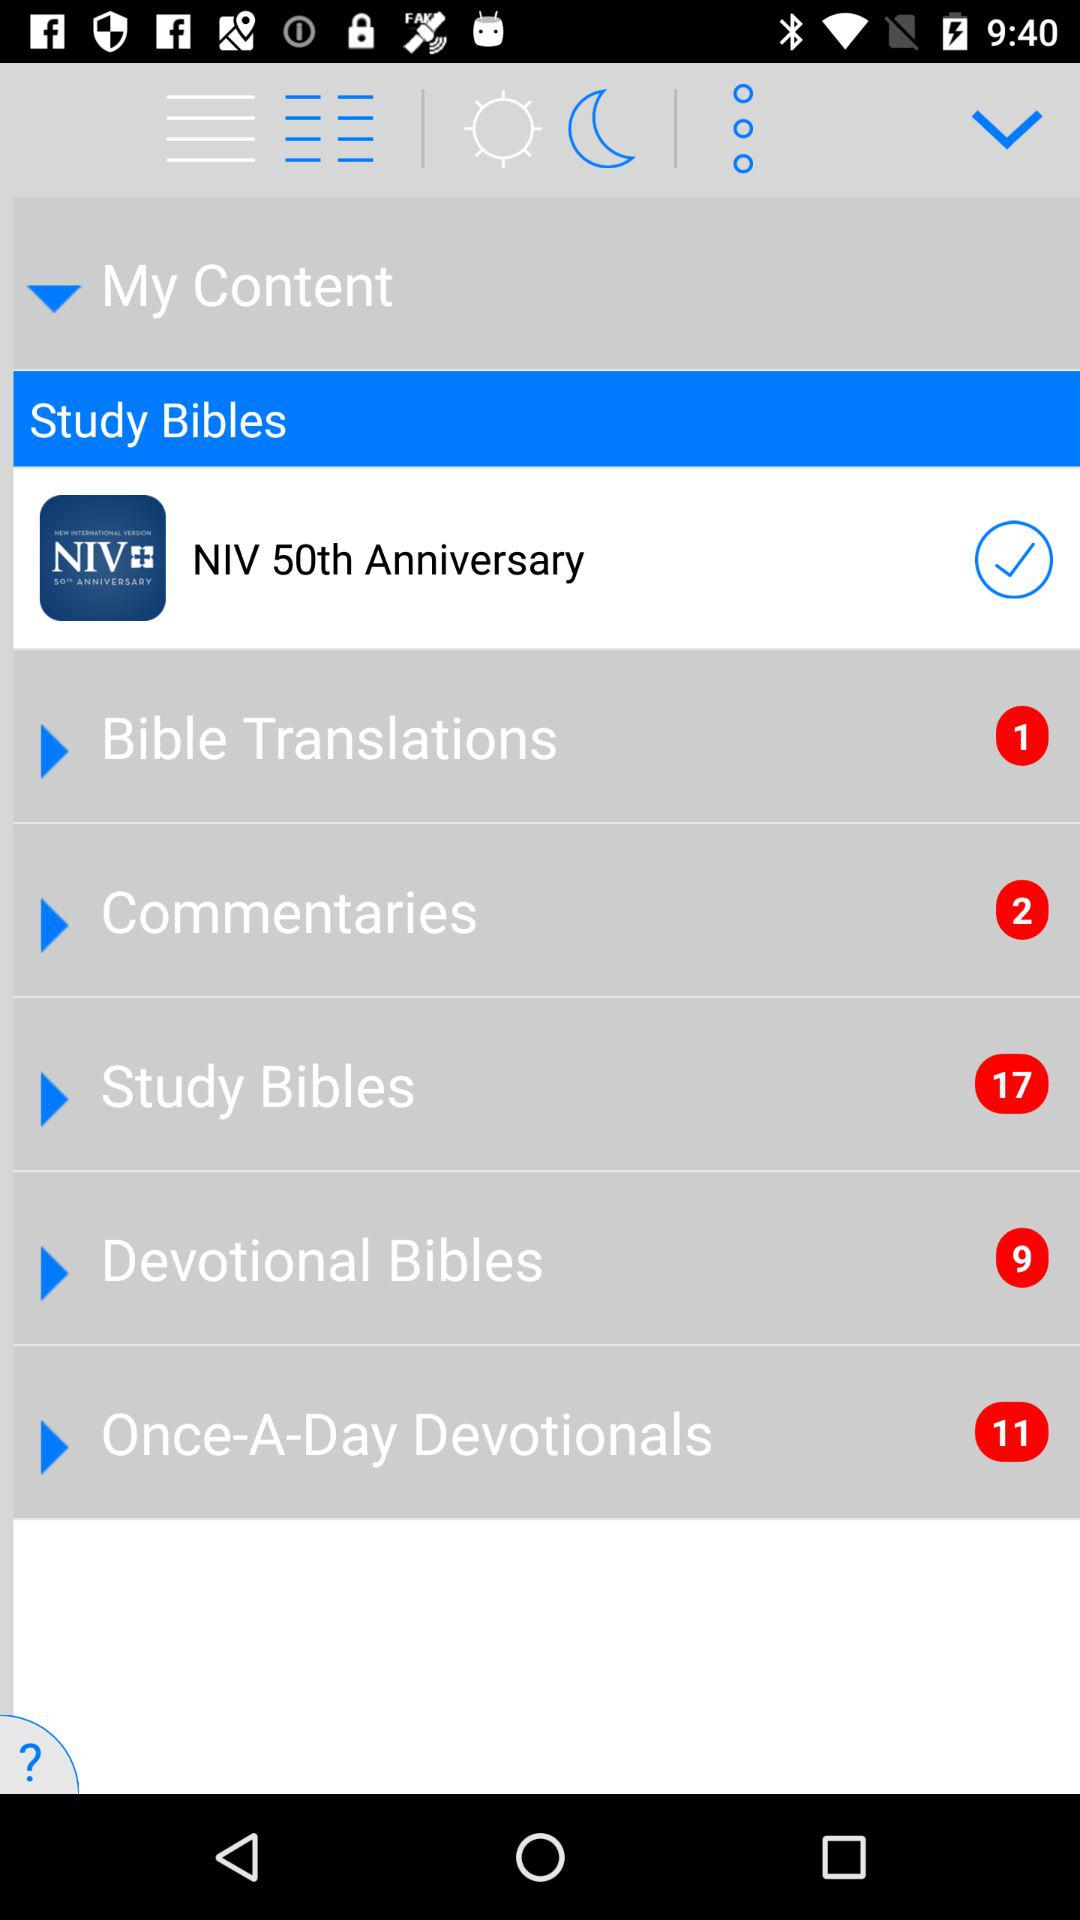How many notifications are pending in "Bible Translations"? There is one notification pending in "Bible Translations". 